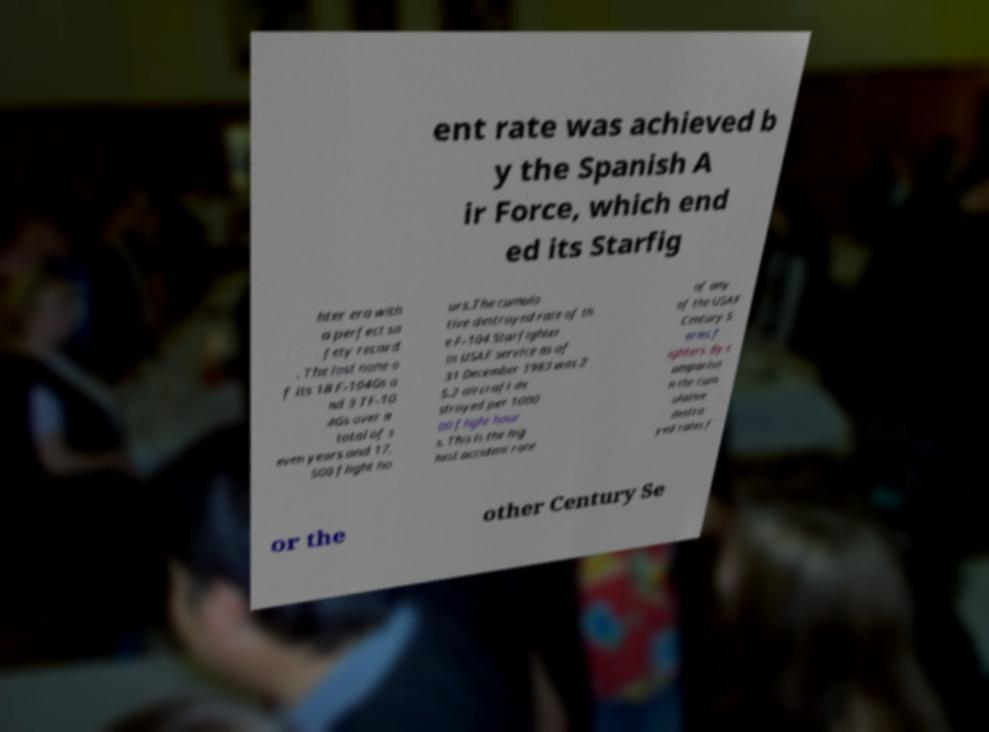Please read and relay the text visible in this image. What does it say? ent rate was achieved b y the Spanish A ir Force, which end ed its Starfig hter era with a perfect sa fety record . The lost none o f its 18 F-104Gs a nd 3 TF-10 4Gs over a total of s even years and 17, 500 flight ho urs.The cumula tive destroyed rate of th e F-104 Starfighter in USAF service as of 31 December 1983 was 2 5.2 aircraft de stroyed per 1000 00 flight hour s. This is the hig hest accident rate of any of the USAF Century S eries f ighters. By c ompariso n the cum ulative destro yed rates f or the other Century Se 